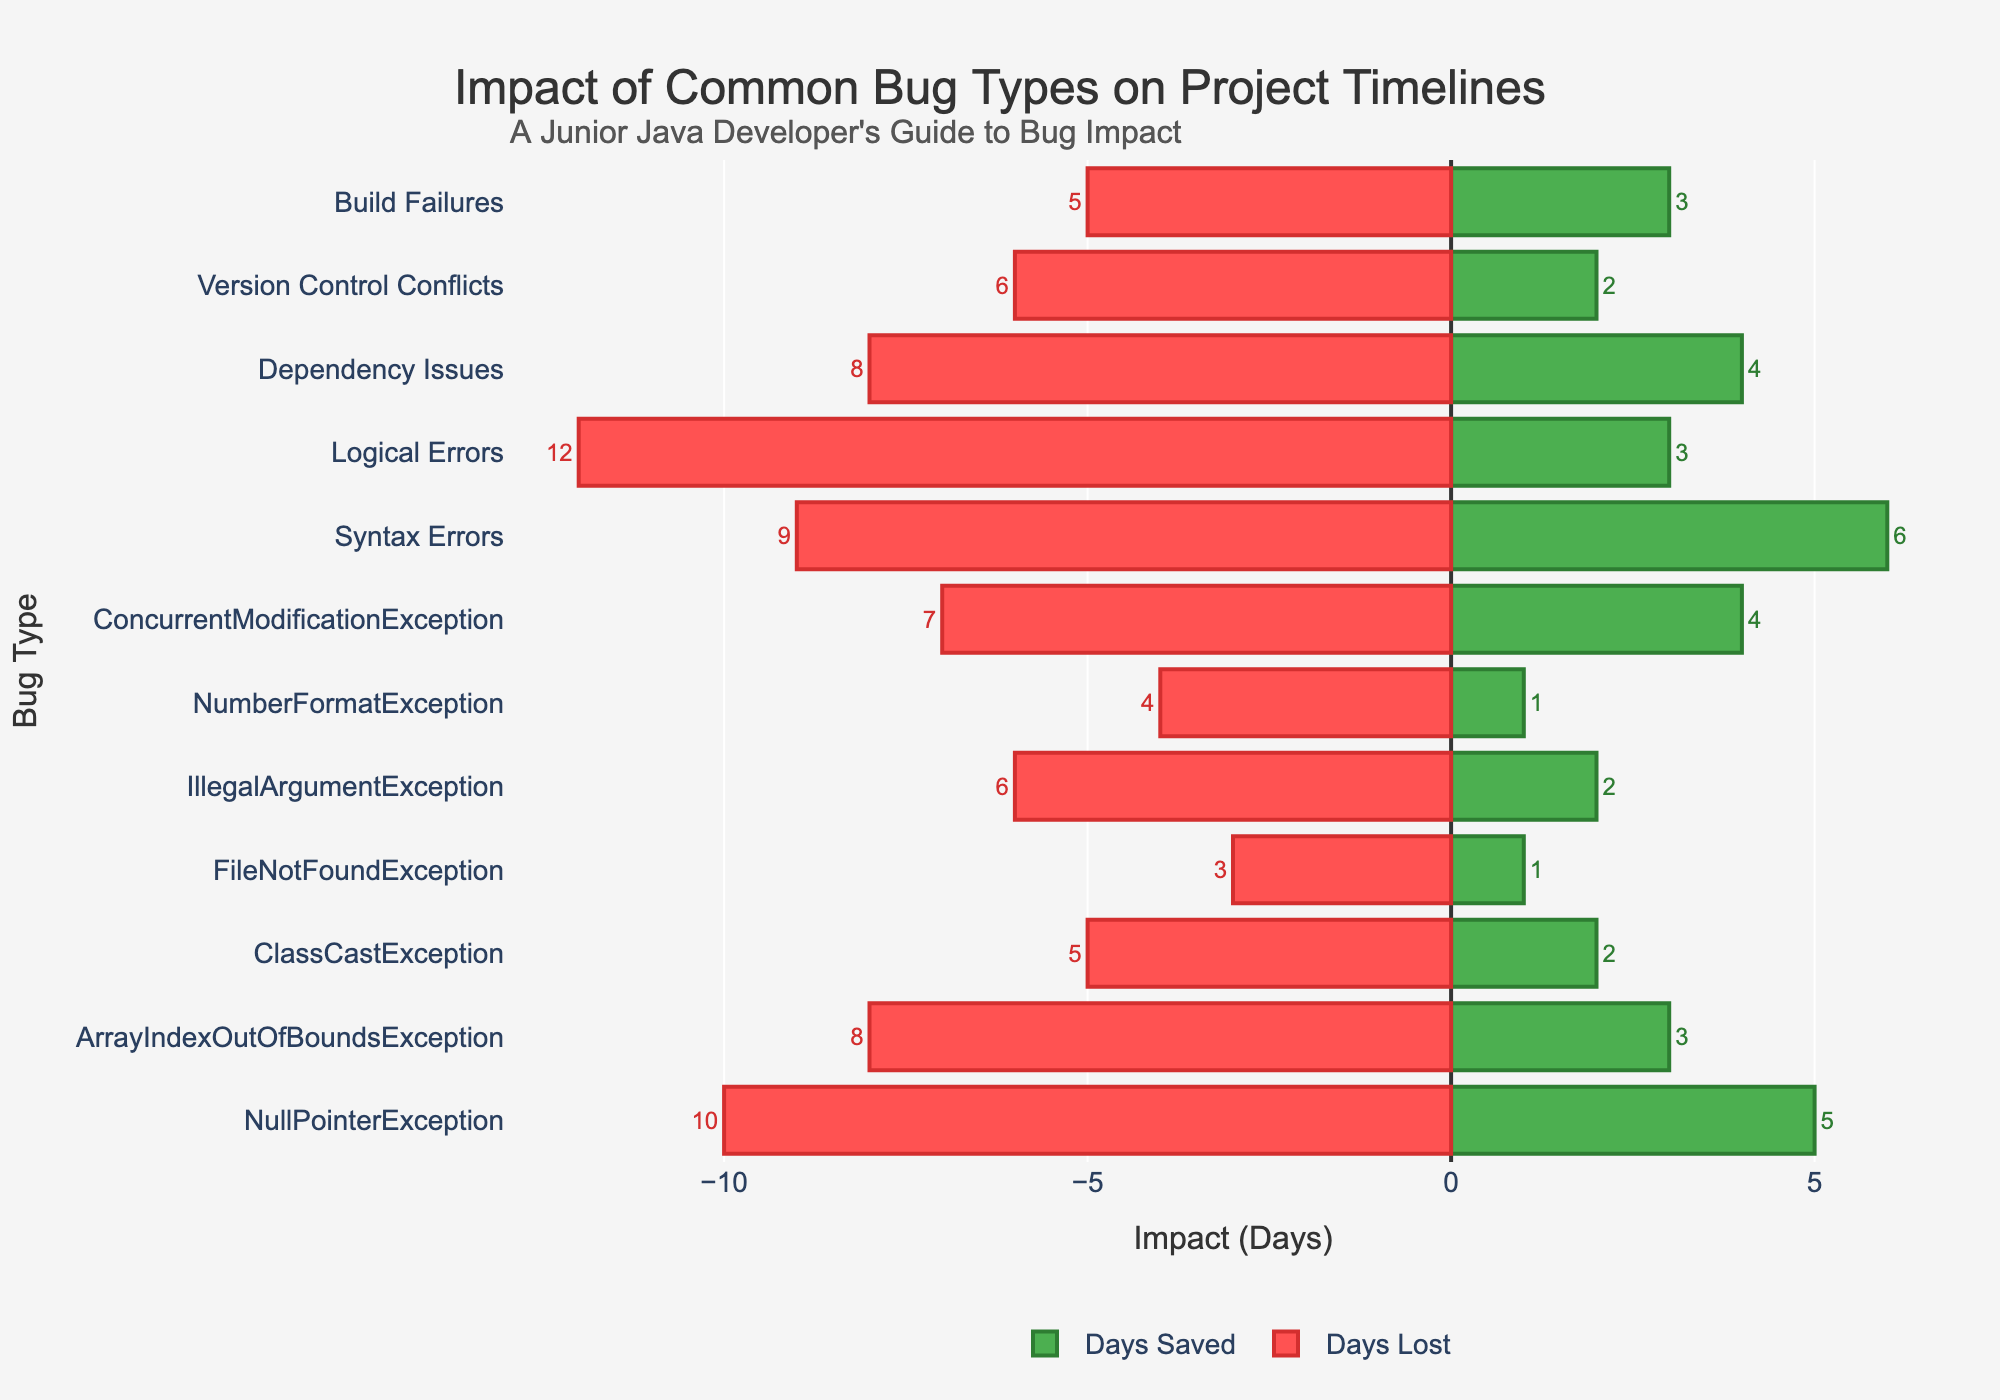Which bug type causes the most days lost? To find the bug type that causes the most days lost, look for the longest red bar in the negative section. Logical Errors have the longest red bar representing 12 days lost.
Answer: Logical Errors Which bug type saves the most days? To identify the bug type that saves the most days, look for the longest green bar in the positive section. Syntax Errors have the longest green bar representing 6 days saved.
Answer: Syntax Errors What's the total impact (both positive and negative) of NumberFormatException? To calculate the total impact, add the absolute values of days saved and days lost for NumberFormatException: 1 (days saved) + 4 (days lost) = 5 days total impact.
Answer: 5 days Which bug type has an equal number of days saved and days lost? By visually comparing the length of green and red bars, only the FileNotFoundException shows almost equal lengths in both directions (1 day saved and 3 days lost). No bug has completely equal days saved and lost.
Answer: None What is the difference in days lost between ArrayIndexOutOfBoundsException and Version Control Conflicts? Calculate the difference in days lost by finding the negative bars of ArrayIndexOutOfBoundsException (8 days lost) and Version Control Conflicts (6 days lost): 8 - 6 = 2 days.
Answer: 2 days Which bug type has the greatest variance between days saved and days lost? To find the greatest variance, calculate the absolute difference between days saved and days lost for each bug type. Logical Errors have the greatest variance with a difference of 12 + 3 = 15 days.
Answer: Logical Errors Are there more positive impacts (days saved) or negative impacts (days lost) for Dependency Issues? Compare the length of the green and red bars for Dependency Issues: 4 days saved vs. 8 days lost. Since 8 is greater than 4, there are more negative impacts.
Answer: Negative impacts What's the total number of days saved across all bugs? To find the total days saved, sum all the positive impact values: 5 + 3 + 2 + 1 + 2 + 1 + 4 + 6 + 3 + 4 + 2 + 3 = 36 days saved.
Answer: 36 days Which bug types have more days saved than days lost? Compare the length of the green and red bars for each bug type. Only ConcurrentModificationException (4 days saved vs. 7 days lost), Syntax Errors (6 days saved vs. 9 days lost), and Dependency Issues (4 days saved vs. 8 days lost) have more days saved than lost.
Answer: Syntax Errors 